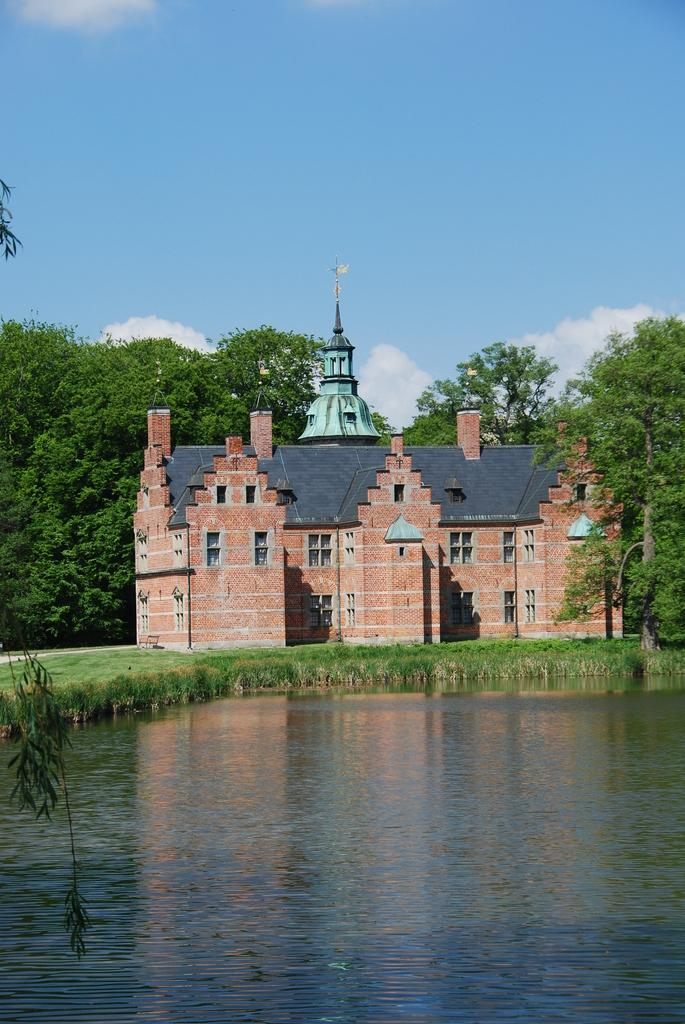What is one of the natural elements present in the image? There is water in the image. What type of vegetation can be seen in the image? There is grass in the image. What type of structure is visible in the image? There is a building in the image. What can be found on the left side of the image? Leaves are visible on the left side of the image. What is visible in the background of the image? There are trees and the sky in the background of the image. What can be observed in the sky? Clouds are present in the sky. What type of behavior is exhibited by the church in the image? There is no church present in the image, so it is not possible to observe any behavior. 